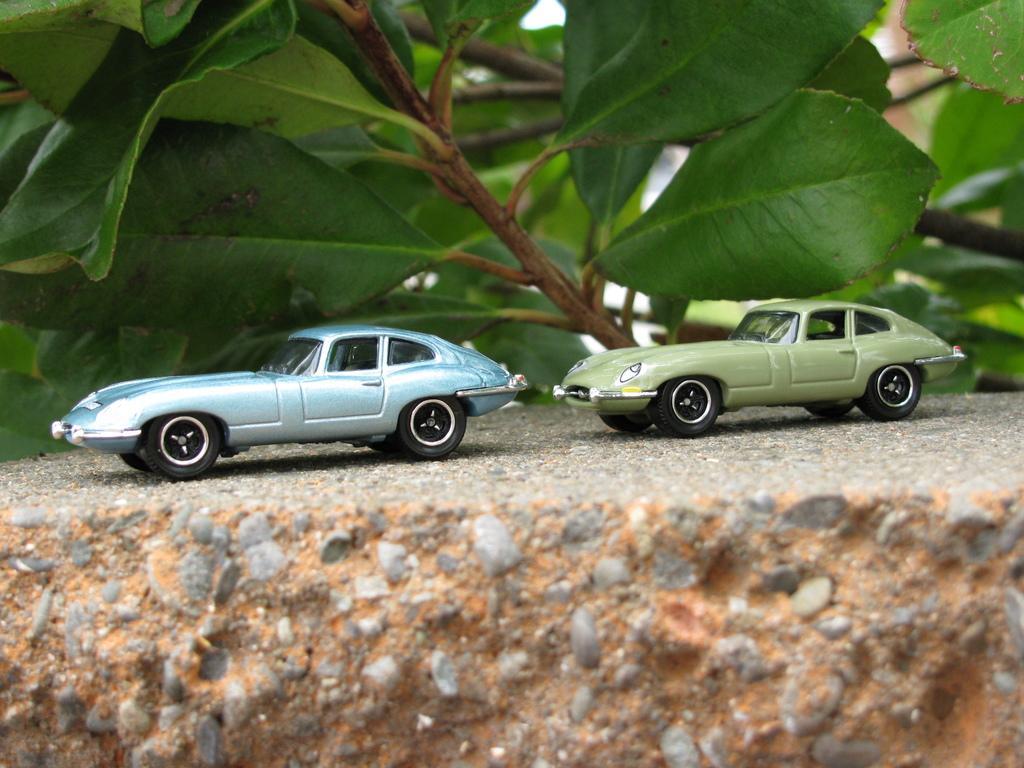Can you describe this image briefly? In this picture i can see two toys car one on the left side and one on the right side. And this is some is plants 